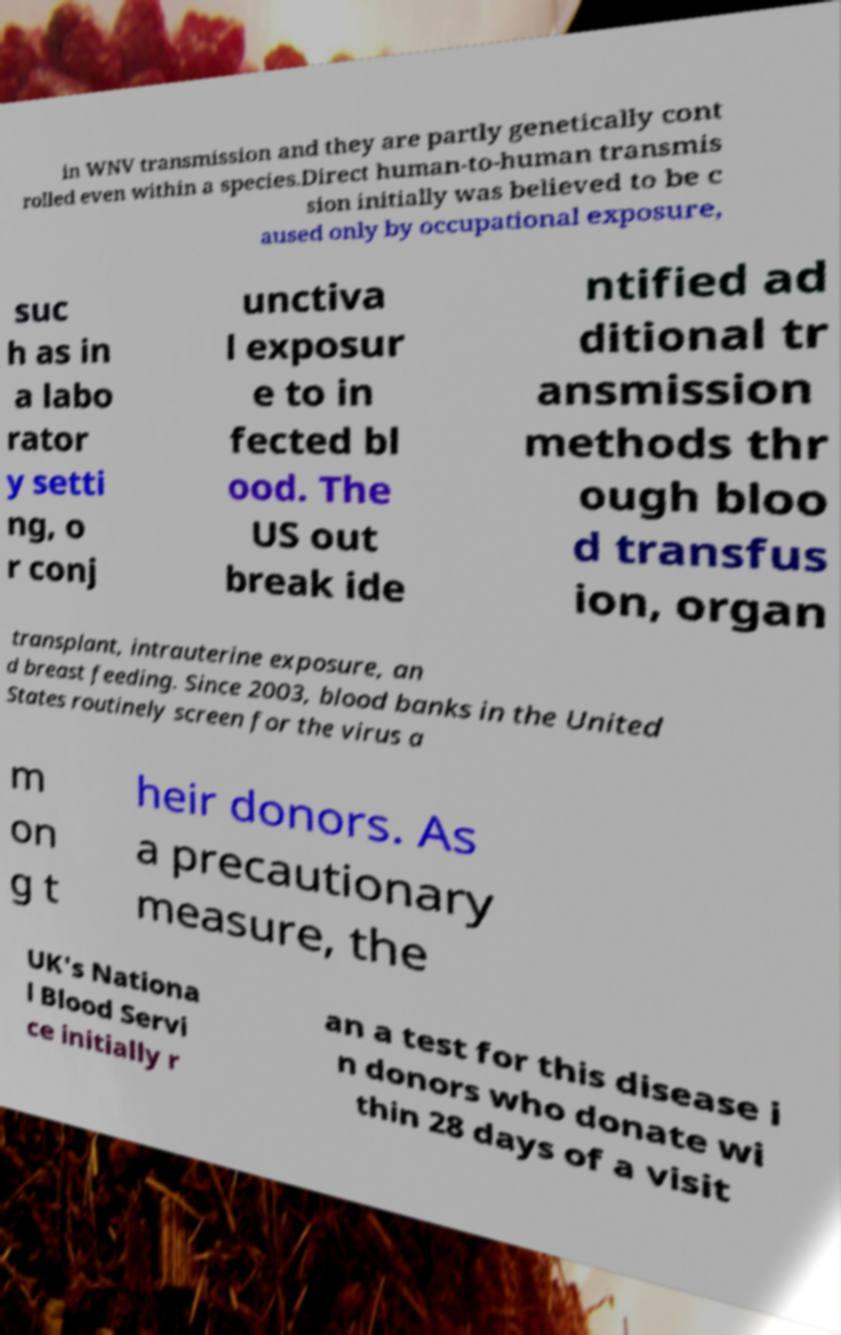Could you extract and type out the text from this image? in WNV transmission and they are partly genetically cont rolled even within a species.Direct human-to-human transmis sion initially was believed to be c aused only by occupational exposure, suc h as in a labo rator y setti ng, o r conj unctiva l exposur e to in fected bl ood. The US out break ide ntified ad ditional tr ansmission methods thr ough bloo d transfus ion, organ transplant, intrauterine exposure, an d breast feeding. Since 2003, blood banks in the United States routinely screen for the virus a m on g t heir donors. As a precautionary measure, the UK's Nationa l Blood Servi ce initially r an a test for this disease i n donors who donate wi thin 28 days of a visit 